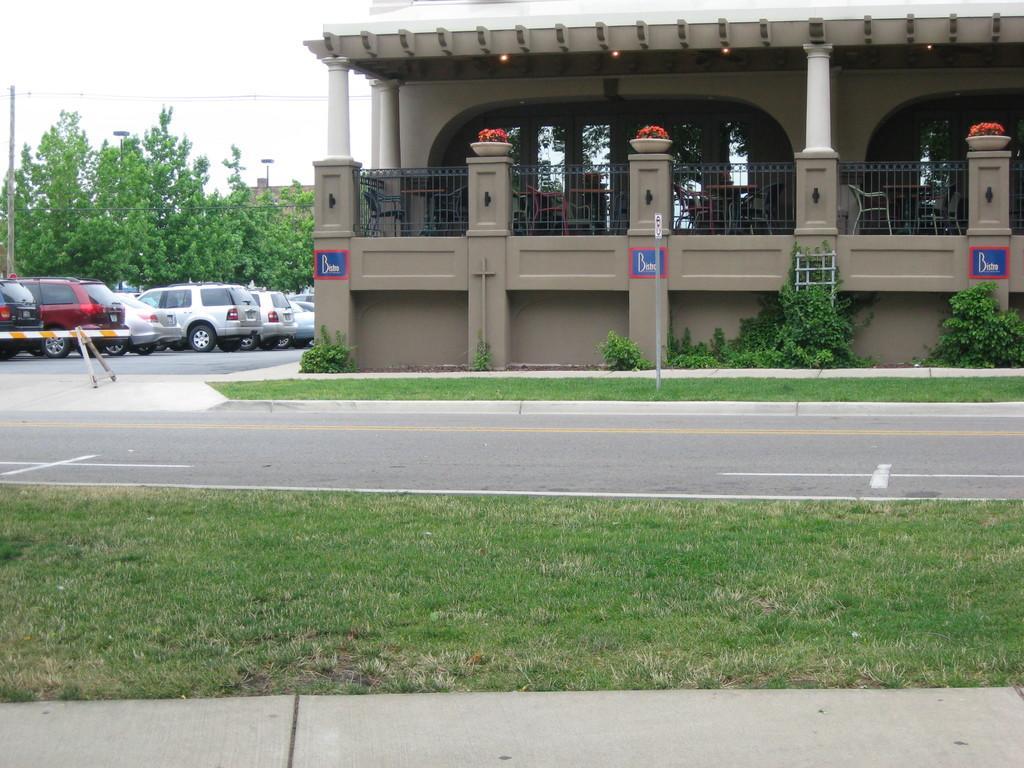How would you summarize this image in a sentence or two? This picture shows a building and we see cars parked and few trees and we see grass on the ground and few plants and couple of poles and we see a cloudy Sky 